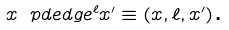<formula> <loc_0><loc_0><loc_500><loc_500>x \ p d e d g e ^ { \ell } x ^ { \prime } \equiv ( x , \ell , x ^ { \prime } ) \text  .</formula> 